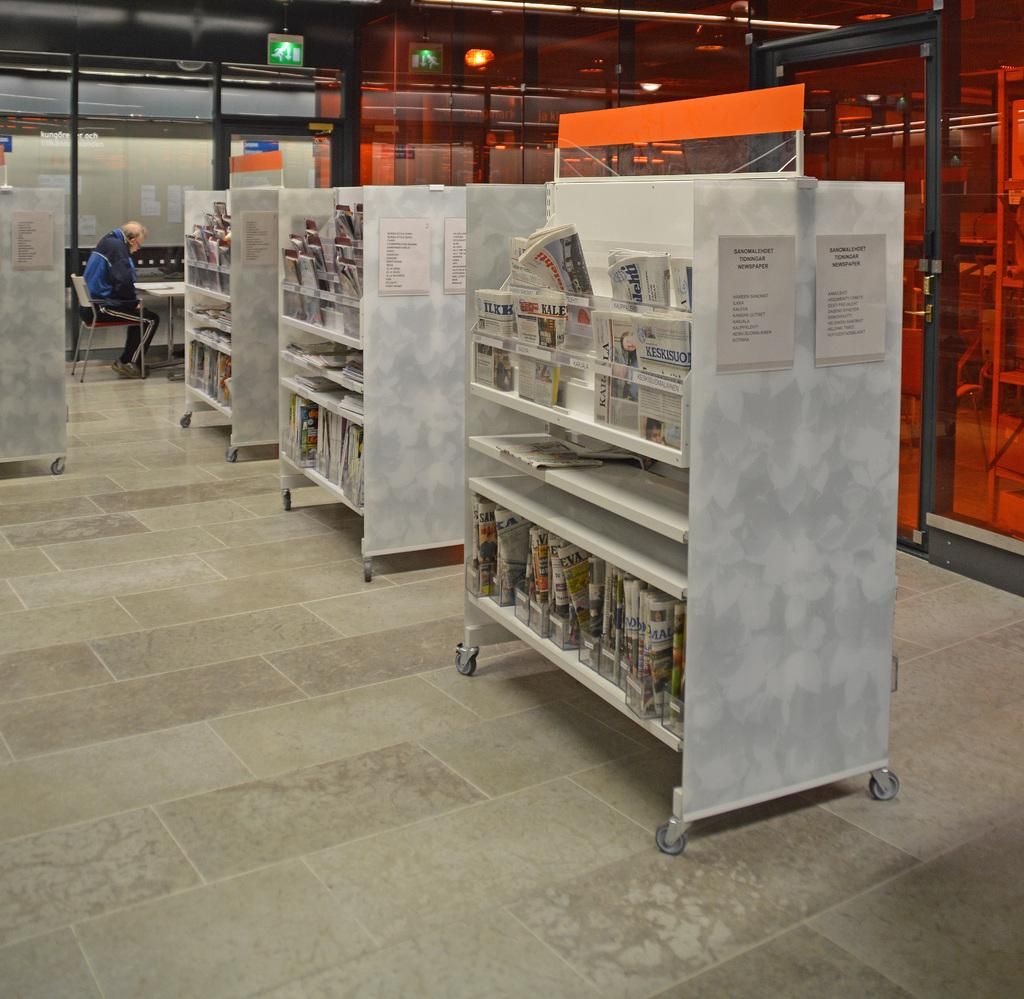Provide a one-sentence caption for the provided image. A library with a movable shelf with a piece of paper that shows the text 'Sanomalehdet Tidnnigar Newspaper'. 